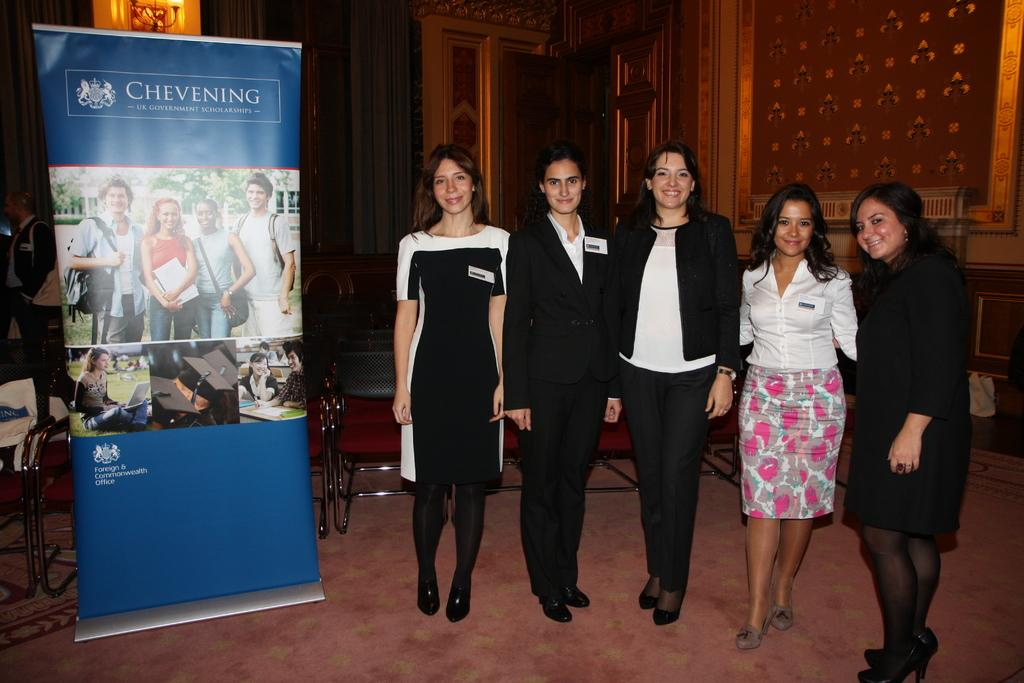What is located on the left side of the image in the foreground? There is a banner in the foreground on the left side of the image. What can be seen in the background of the image? Chairs are visible in the background of the image. How many women are standing on the right side of the image? There are five women standing on the right side of the image. What is present in the background of the image besides the chairs? There is a wall in the background of the image. What type of pencil is being used by the grandmother in the image? There is no grandmother or pencil present in the image. Are the five women standing on the right side of the image sisters? The provided facts do not mention any familial relationships between the women, so we cannot determine if they are sisters. 